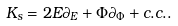Convert formula to latex. <formula><loc_0><loc_0><loc_500><loc_500>K _ { s } = 2 E \partial _ { E } + \Phi \partial _ { \Phi } + c . c . .</formula> 